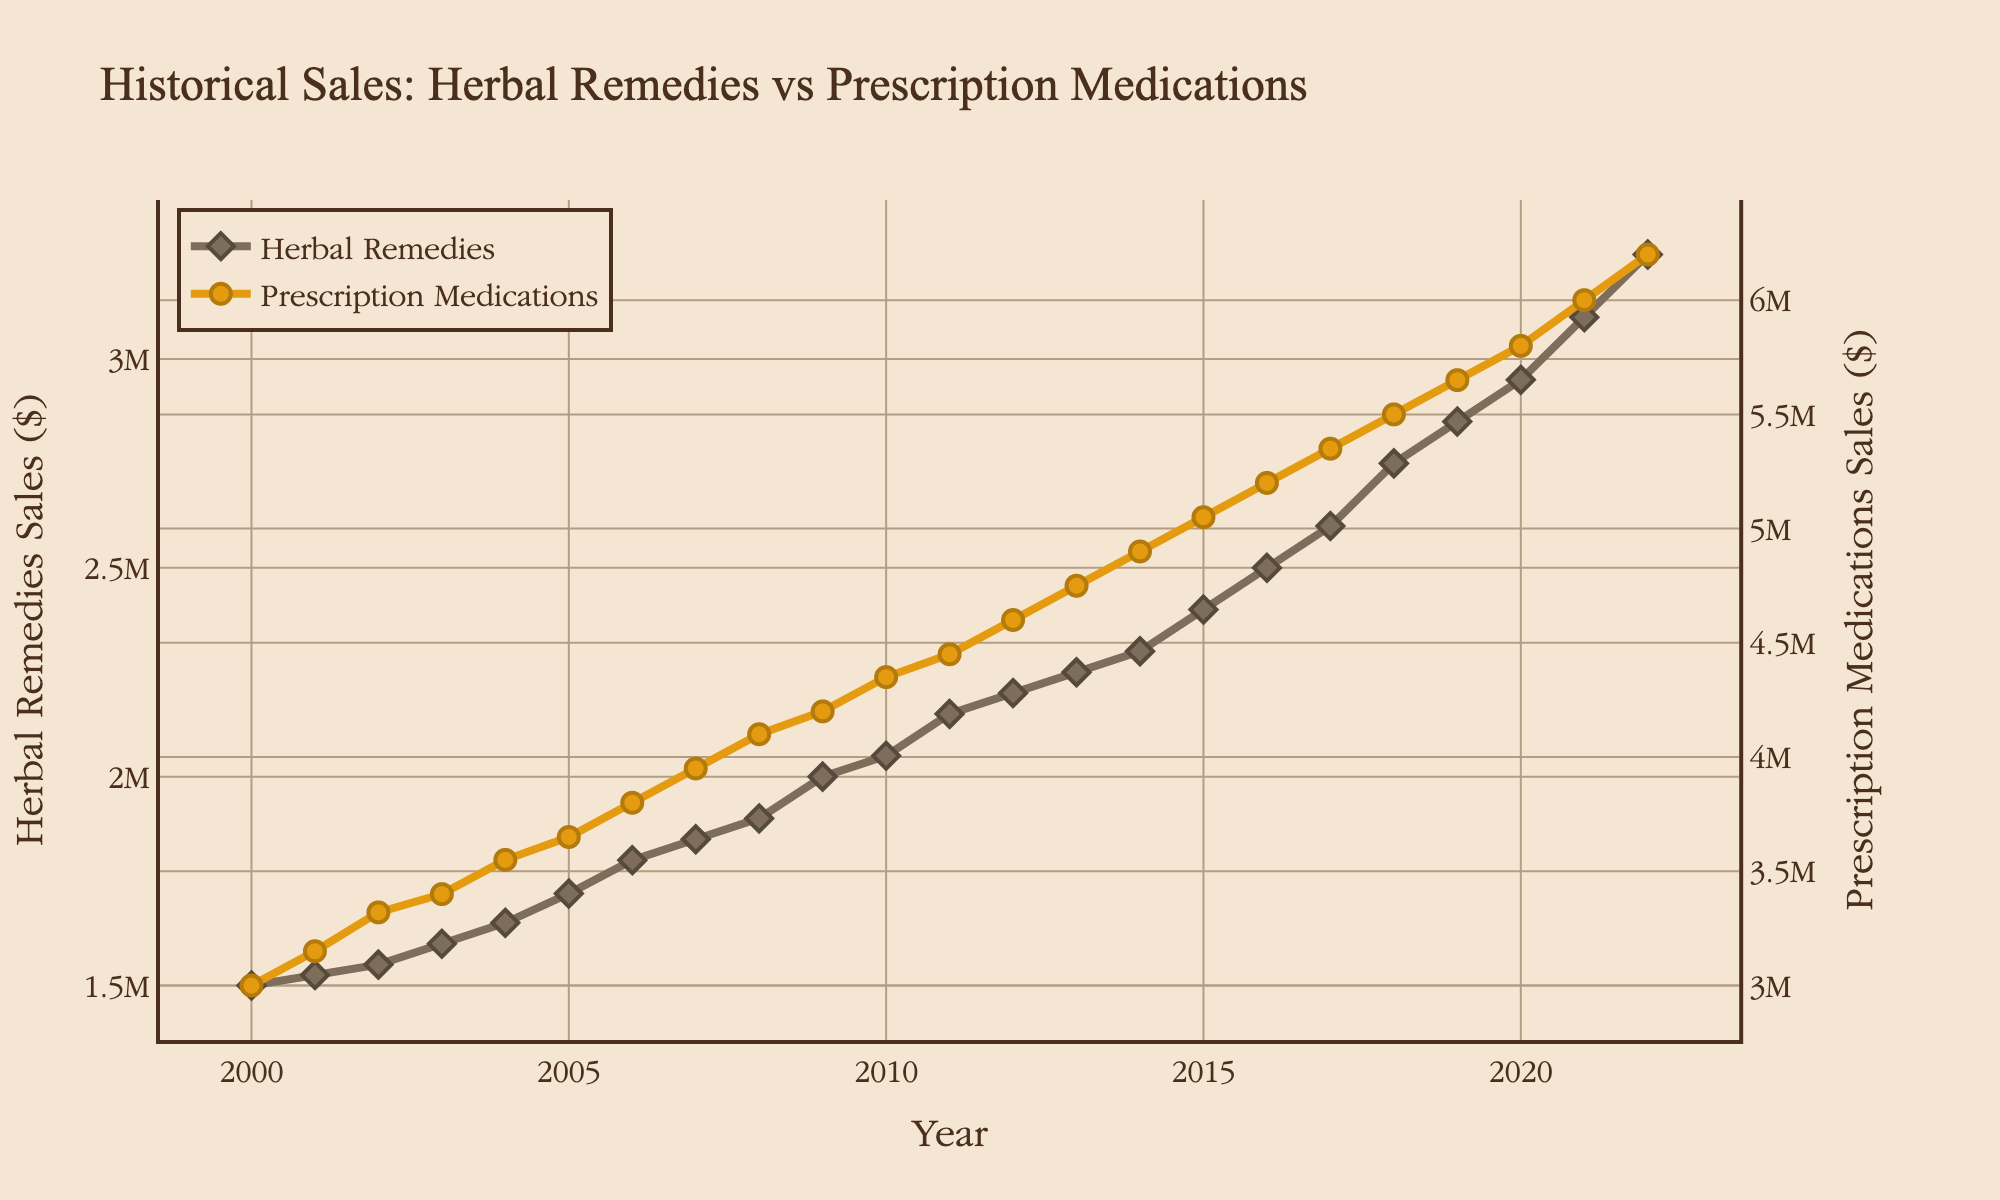What is the title of the plot? The title of the plot is located at the top and clearly states the main focus of the data being displayed.
Answer: Historical Sales: Herbal Remedies vs Prescription Medications Which year had the highest sales of traditional herbal remedies? By examining the line representing traditional herbal remedies, we notice that the highest point on this line occurs at the year 2022.
Answer: 2022 What is the sales value of prescription medications in the year 2015? Locate the year 2015 on the x-axis and trace vertically up to the prescription medications line, where the value reads 5050000.
Answer: $5,050,000 How do the sales of traditional herbal remedies compare to prescription medications in 2010? Look at the year 2010 and note the sales values for both lines: the herbal remedies value is lower at 2050000 compared to the prescription medications value of 4350000.
Answer: Herbal remedies sales are lower What is the overall trend for traditional herbal remedies sales from 2000 to 2022? The line for traditional herbal remedies sales shows an upward trajectory from 1500000 in 2000 to 3250000 in 2022, indicating a consistent increase.
Answer: Increasing What year marks the first time sales of traditional herbal remedies reached 2 million dollars? Follow the herbal remedies line and identify the first year where the sales value reaches or exceeds 2000000, which is 2009.
Answer: 2009 In what year did the sales of prescription medications reach 60 million dollars? Identify the data point on the prescription medications line that reaches 6000000, which corresponds to the year 2021.
Answer: 2021 What is the difference in sales between traditional herbal remedies and prescription medications in 2018? In 2018, the sales for herbal remedies are 2750000, and for prescription medications, it is 5500000; the difference is 2750000.
Answer: $2,750,000 What was the average annual sales growth for traditional herbal remedies from 2009 to 2015? The sales in 2009 were 2000000, and by 2015 it was 2400000. The growth is 400000 over 6 years, so the average annual growth is 400000 / 6 ≈ 66667.
Answer: $66,667 Which type of medication had a steeper growth rate between 2000 and 2022? The slope of the line for traditional herbal remedies and prescription medications both show upward trends, but by visual inspection, the prescription medications line has a steeper incline.
Answer: Prescription medications 